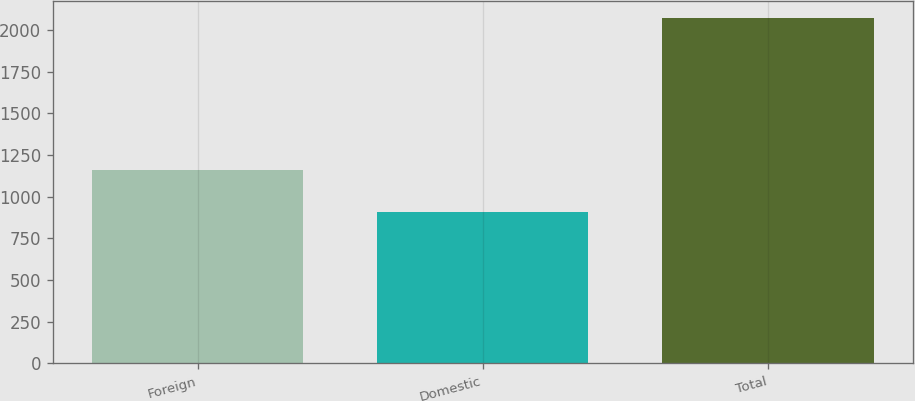<chart> <loc_0><loc_0><loc_500><loc_500><bar_chart><fcel>Foreign<fcel>Domestic<fcel>Total<nl><fcel>1163<fcel>908<fcel>2071<nl></chart> 